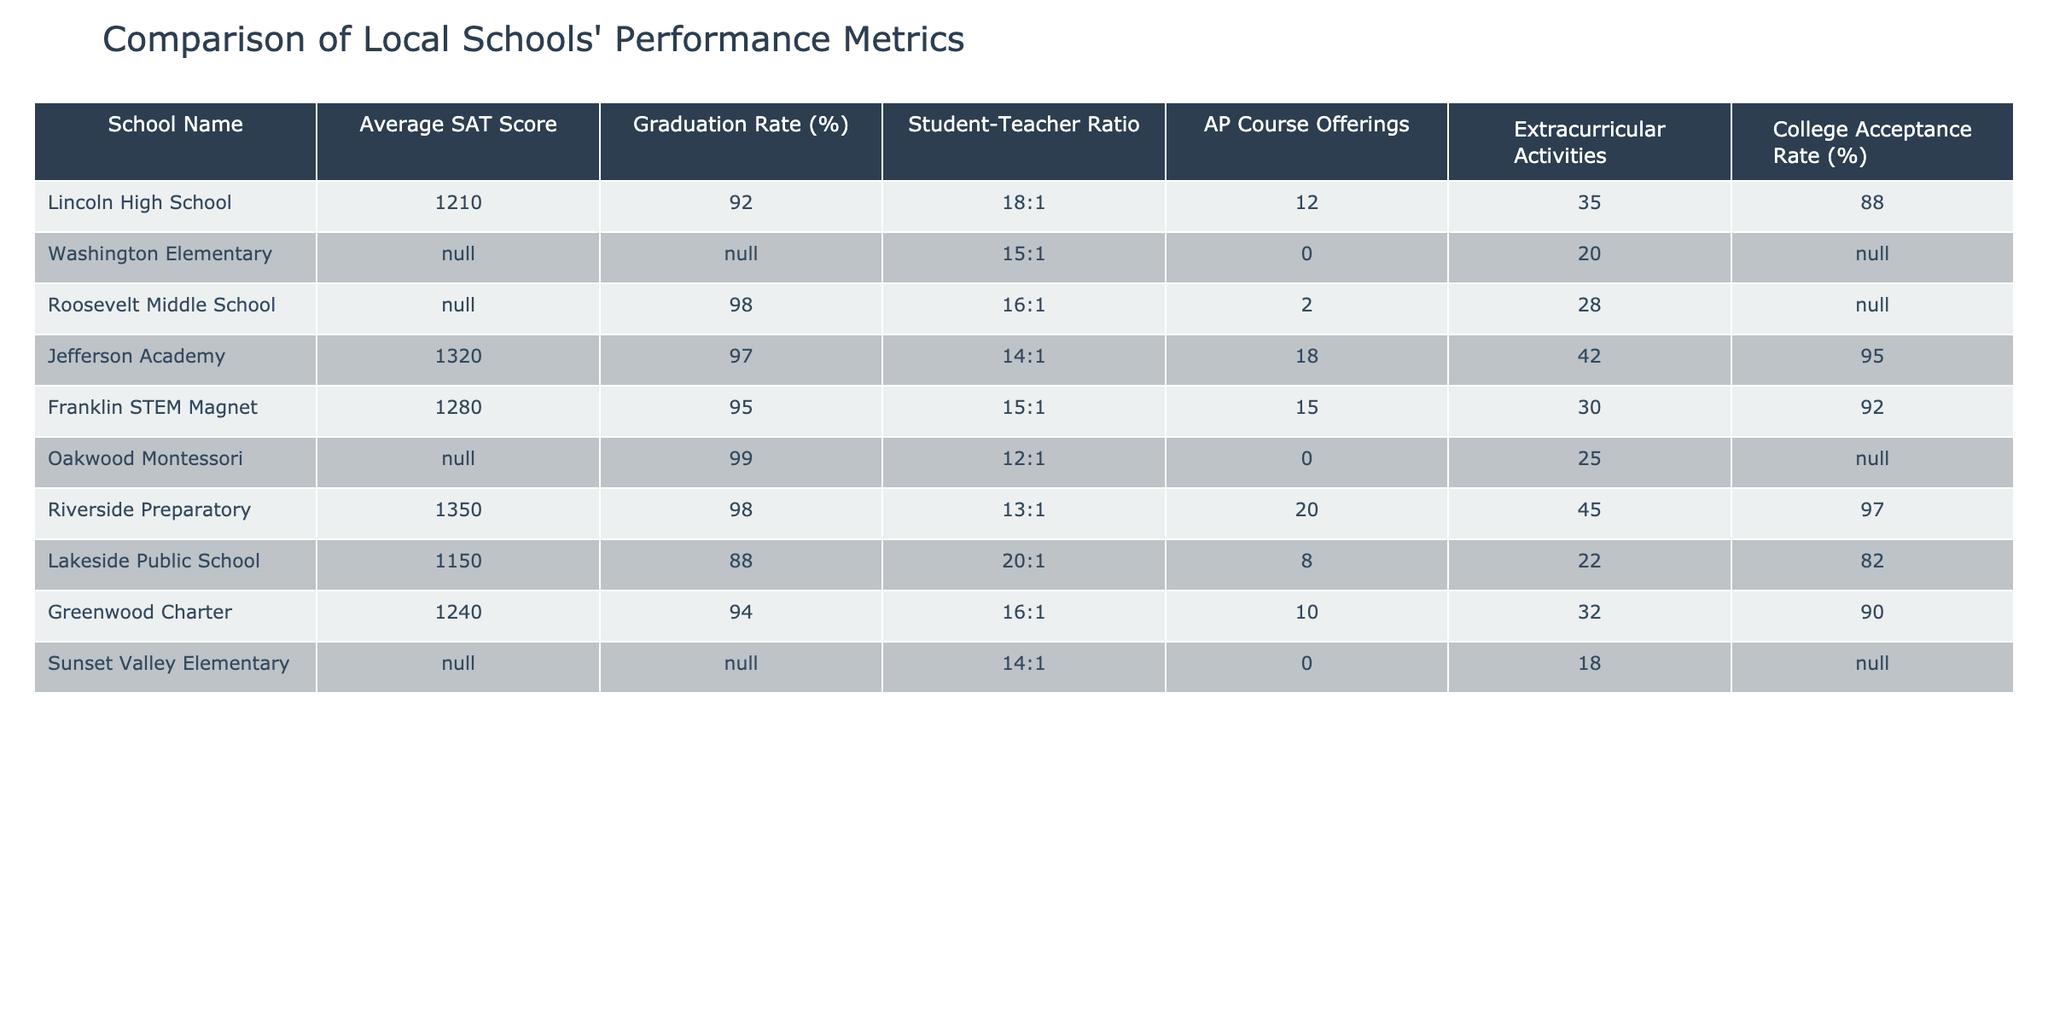What is the highest average SAT score among the schools? By examining the SAT scores in the table, Riverside Preparatory has the highest score of 1350.
Answer: 1350 Which school has the lowest graduation rate? The graduation rates of the schools are listed, and Lakeside Public School has the lowest rate at 88%.
Answer: 88% How many AP Course Offerings does Jefferson Academy have? Jefferson Academy's row shows it has 18 AP Course Offerings listed in the table.
Answer: 18 Is there a school with a student-teacher ratio better than 14:1? Comparing the student-teacher ratios in the table, Jefferson Academy has a ratio of 14:1, which is optimal as it is not greater than 14:1.
Answer: No What is the average college acceptance rate of the schools listed? To find the average, we add the college acceptance rates: (88 + 95 + 92 + 97 + 90 + 82) = 544 and count the number of schools to be 6, then divide 544 by 6, which gives us approximately 90.67%.
Answer: 90.67% How many schools have an AP Course Offering count that is greater than 10? By reviewing the table, we see that there are 6 schools (Jefferson Academy, Franklin STEM Magnet, Riverside Preparatory, Greenwood Charter) with more than 10 AP Course Offerings.
Answer: 4 What is the student-teacher ratio at Roosevelt Middle School? The table lists Roosevelt Middle School with a student-teacher ratio of 16:1.
Answer: 16:1 Can we conclude that Oakwood Montessori has a higher graduation rate than Lincoln High School? According to the table, Oakwood Montessori has a graduation rate of 99%, which is higher than Lincoln High School’s rate of 92%.
Answer: Yes Which school has the most extracurricular activities? The table shows that Riverside Preparatory has the most extracurricular activities listed at 45.
Answer: 45 How does the average SAT score for schools with a graduation rate above 95% compare to those below? The schools above 95% graduation rate are Jefferson Academy (1320), Franklin STEM Magnet (1280), Roosevelt Middle School (N/A, excluded), and Riverside Preparatory (1350) which average to (1320+1280+1350)/3 = 1316.67. The only school below that threshold with a score is Lakeside Public School (1150), giving us a lower average of 1150.
Answer: 1316.67 is higher 